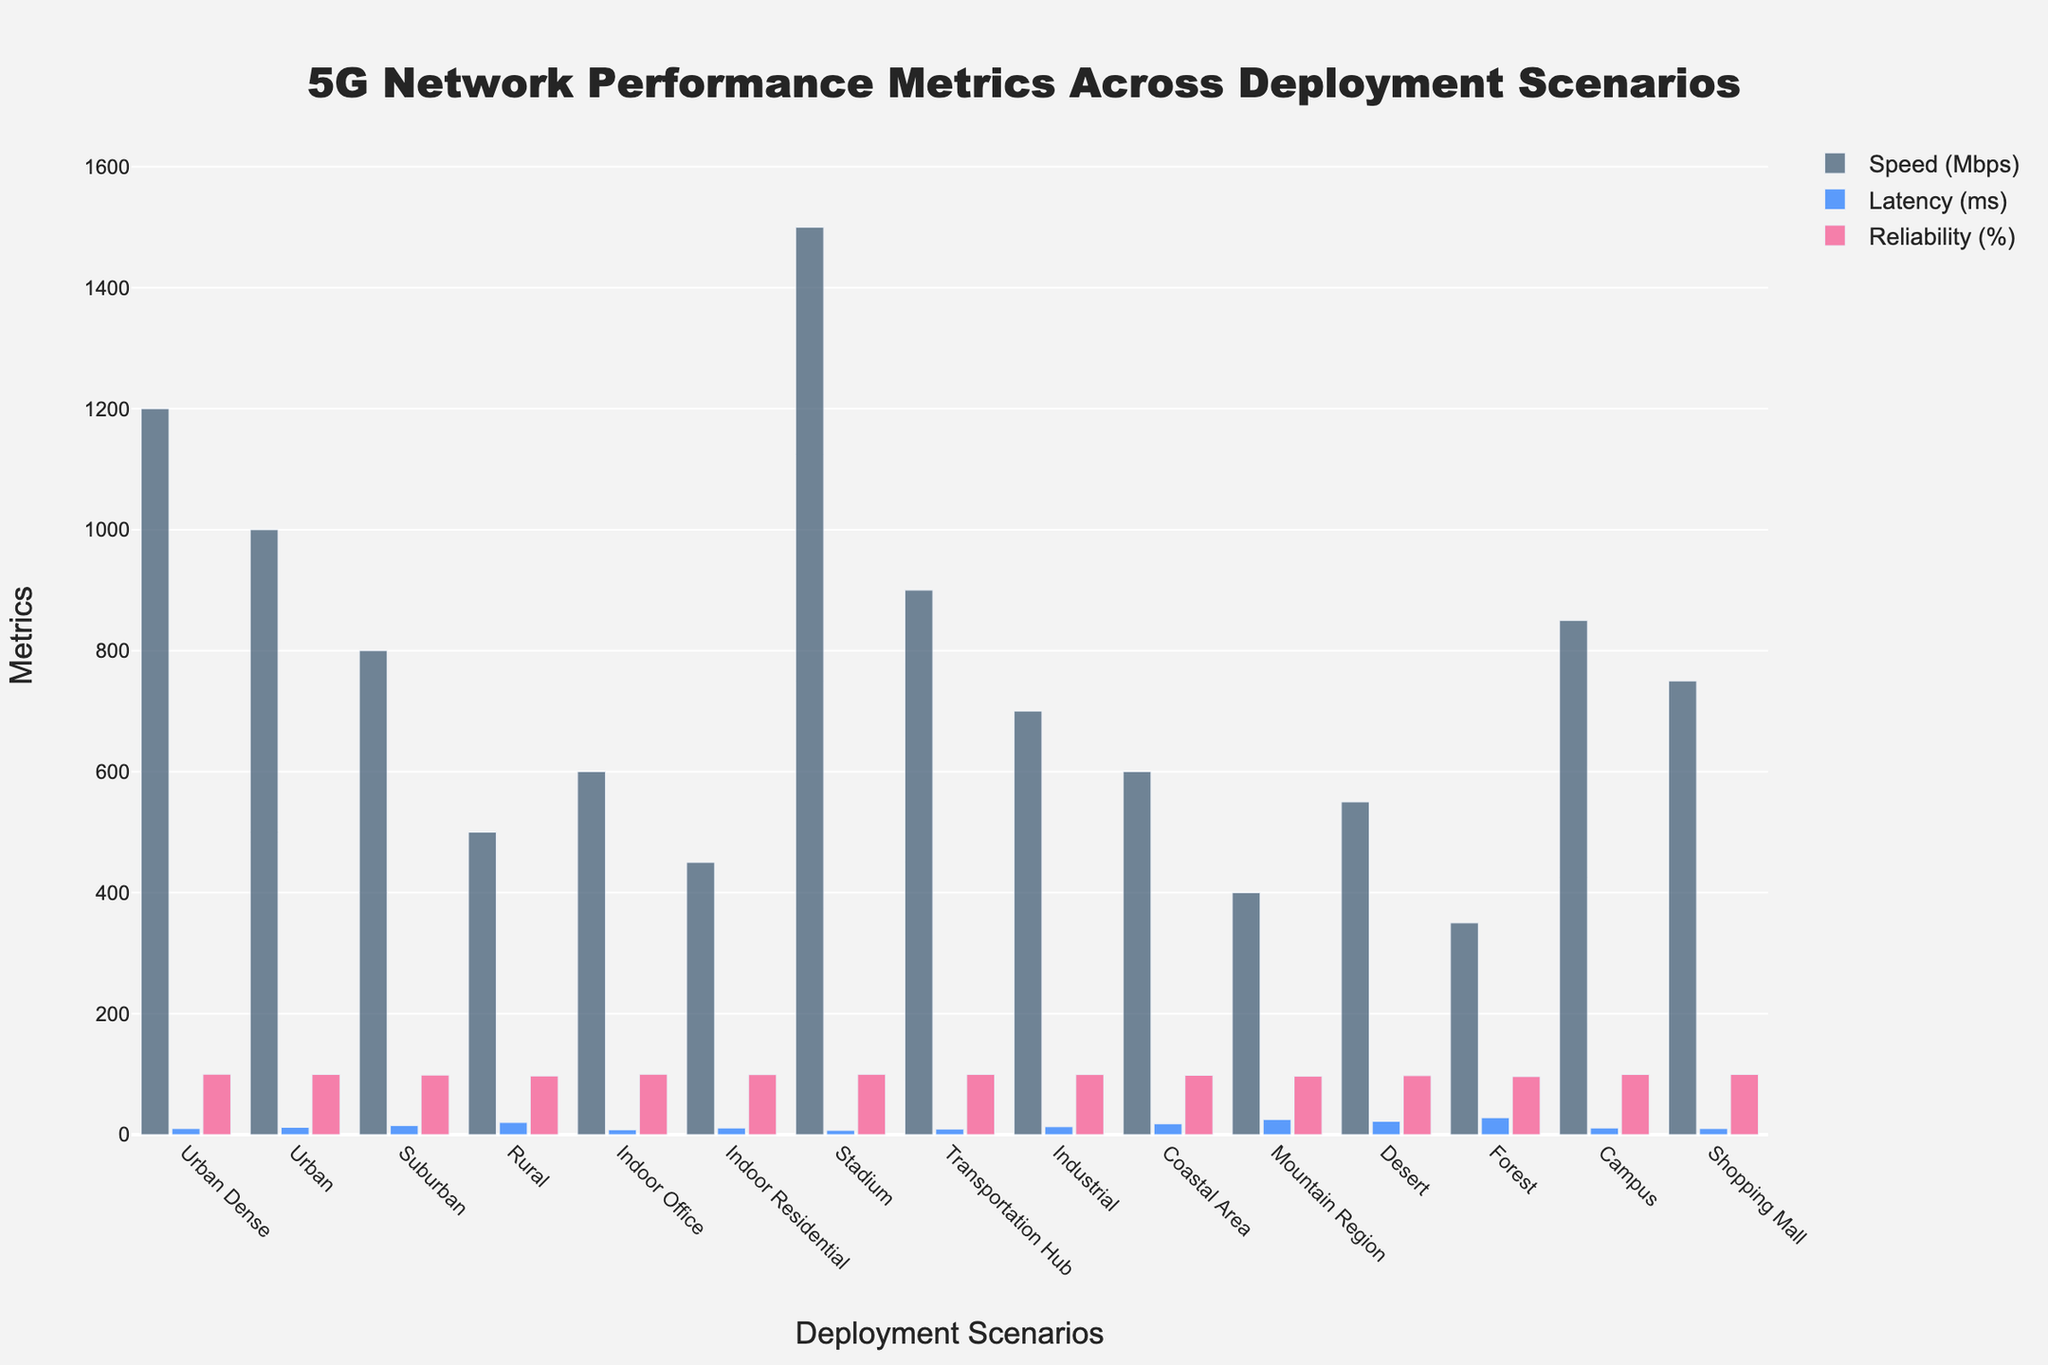Which scenario has the highest speed? By visually inspecting the bar heights, the Stadium scenario has the tallest bar for speed, indicating the highest speed (1500 Mbps).
Answer: Stadium What is the difference in latency between the Urban Dense and Rural scenarios? The latency for Urban Dense is 10 ms, and for Rural, it is 20 ms. The difference is 20 - 10 = 10 ms.
Answer: 10 ms Which deployment scenario shows the lowest reliability percentage? By comparing the heights of the reliability bars, the Forest scenario shows the shortest bar for reliability, indicating the lowest reliability (96.0%).
Answer: Forest How much higher is the speed in Urban areas compared to Suburban areas? The speed in Urban areas is 1000 Mbps, while in Suburban areas, it is 800 Mbps. The difference is 1000 - 800 = 200 Mbps.
Answer: 200 Mbps What is the average latency across all scenarios? Add the latency values for all scenarios (10 + 12 + 15 + 20 + 8 + 11 + 7 + 9 + 13 + 18 + 25 + 22 + 28 + 11 + 10) = 209 ms. There are 15 scenarios, so the average latency is 209 / 15 ≈ 13.93 ms.
Answer: 13.93 ms Which scenario has the lowest speed, and what is its value? By examining the speed bars, the Forest scenario has the shortest bar for speed, indicating the lowest speed (350 Mbps).
Answer: Forest, 350 Mbps Is the reliability in Coastal Areas higher or lower than in Industrial areas? Comparing the heights of the reliability bars, the reliability in Coastal Areas (98.0%) is lower than in Industrial areas (99.3%).
Answer: Lower What is the total speed of all urban-related scenarios (Urban Dense, Urban, Suburban)? Sum the speed values of Urban Dense (1200 Mbps), Urban (1000 Mbps), and Suburban (800 Mbps). The total is 1200 + 1000 + 800 = 3000 Mbps.
Answer: 3000 Mbps How does the latency in Indoor Office compare to Transportation Hub? By comparing the height of the latency bars, latency in Indoor Office (8 ms) is lower than Transportation Hub (9 ms).
Answer: Lower What is the overall range of reliability percentages across all deployment scenarios? The highest reliability is 99.9% (Urban Dense), and the lowest is 96.0% (Forest). The range is 99.9% - 96.0% = 3.9%.
Answer: 3.9% 